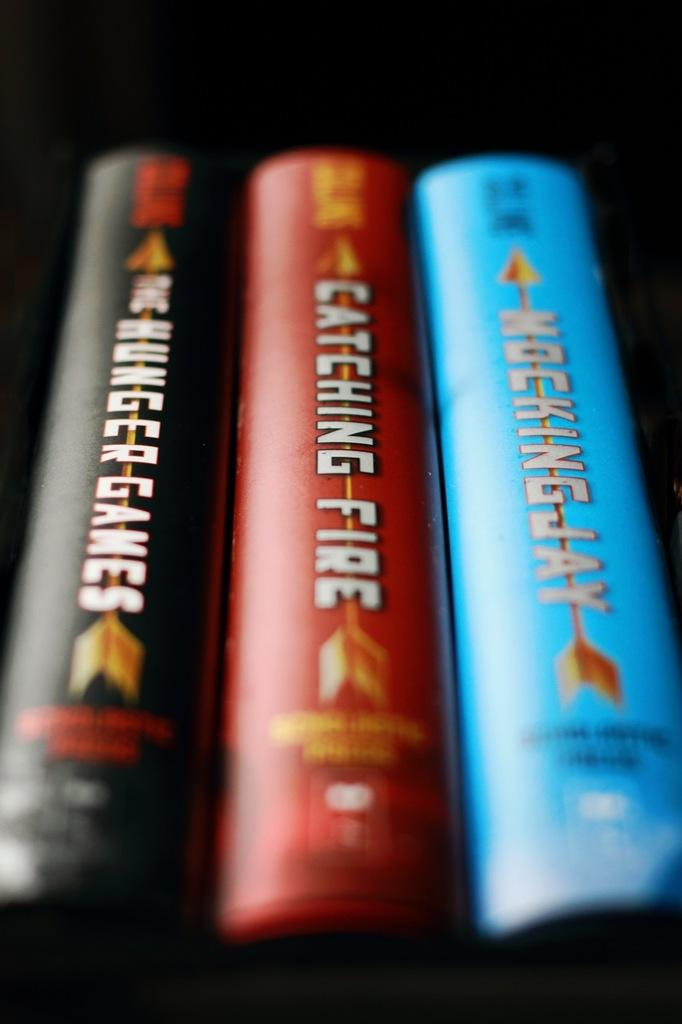<image>
Render a clear and concise summary of the photo. a row of books with the middle one titled 'catching fire' 